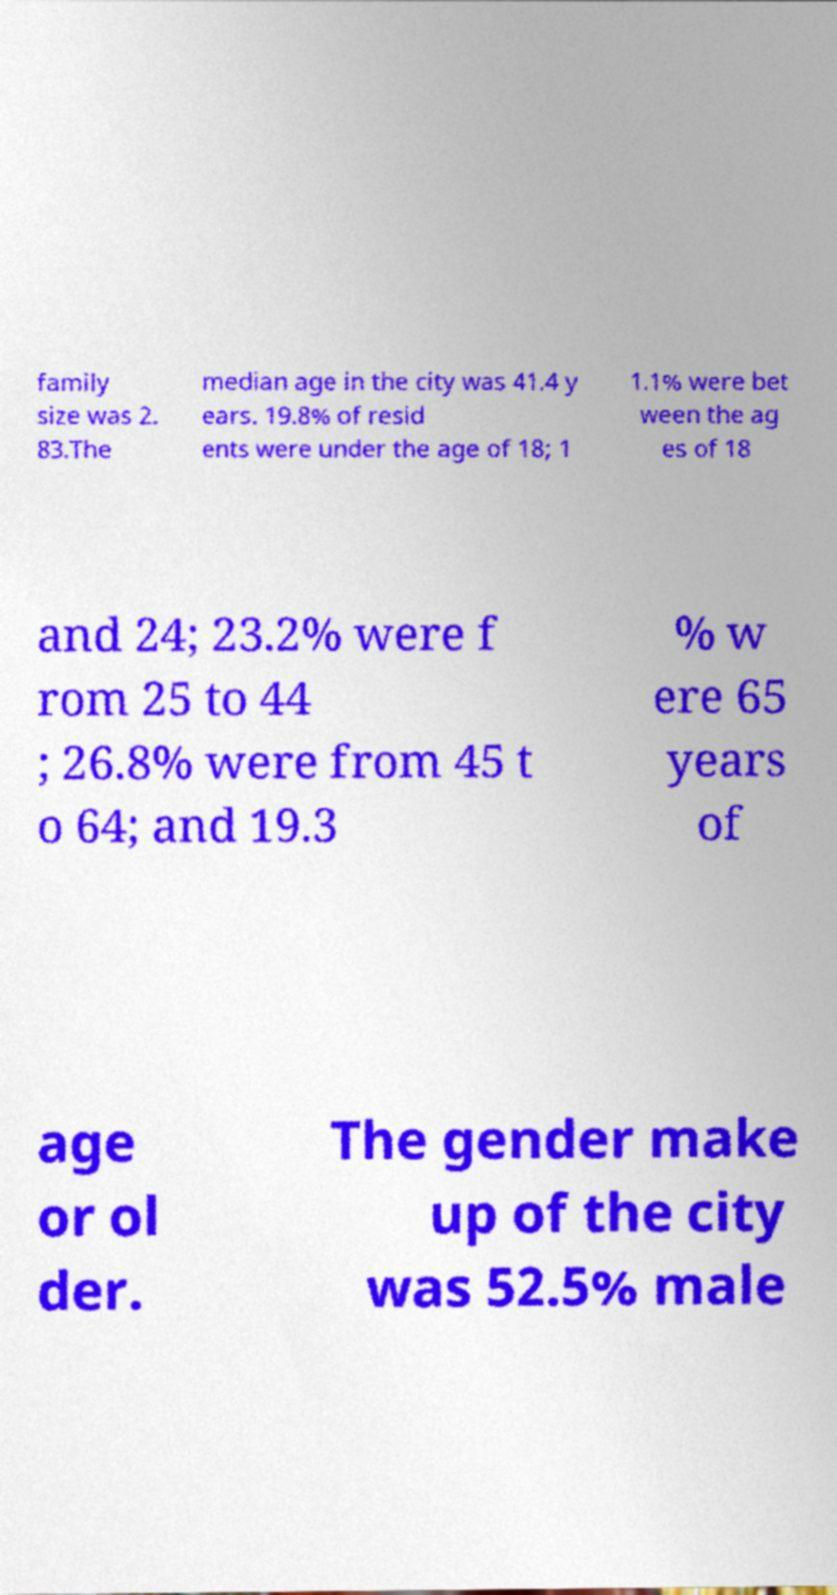Please read and relay the text visible in this image. What does it say? family size was 2. 83.The median age in the city was 41.4 y ears. 19.8% of resid ents were under the age of 18; 1 1.1% were bet ween the ag es of 18 and 24; 23.2% were f rom 25 to 44 ; 26.8% were from 45 t o 64; and 19.3 % w ere 65 years of age or ol der. The gender make up of the city was 52.5% male 